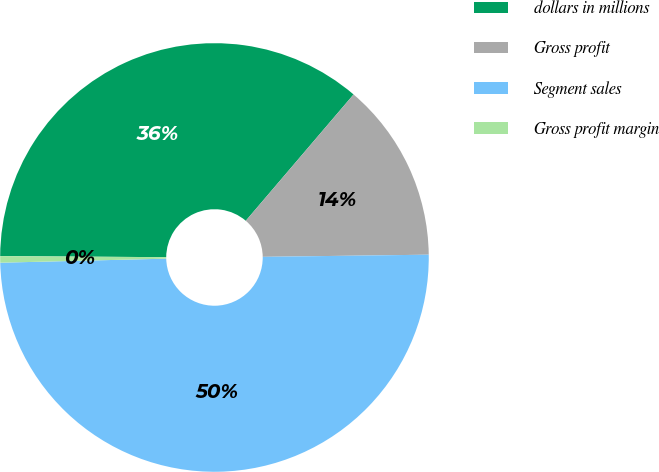Convert chart to OTSL. <chart><loc_0><loc_0><loc_500><loc_500><pie_chart><fcel>dollars in millions<fcel>Gross profit<fcel>Segment sales<fcel>Gross profit margin<nl><fcel>36.14%<fcel>13.55%<fcel>49.82%<fcel>0.49%<nl></chart> 